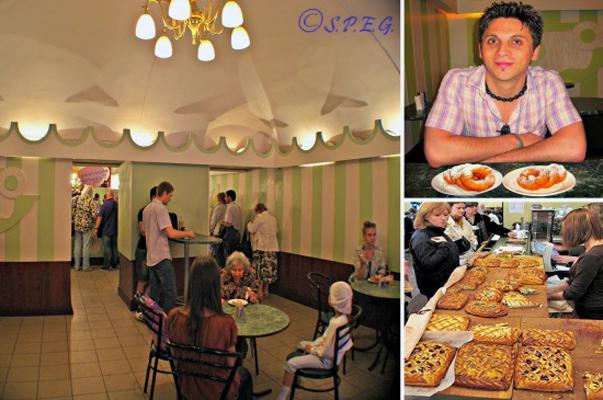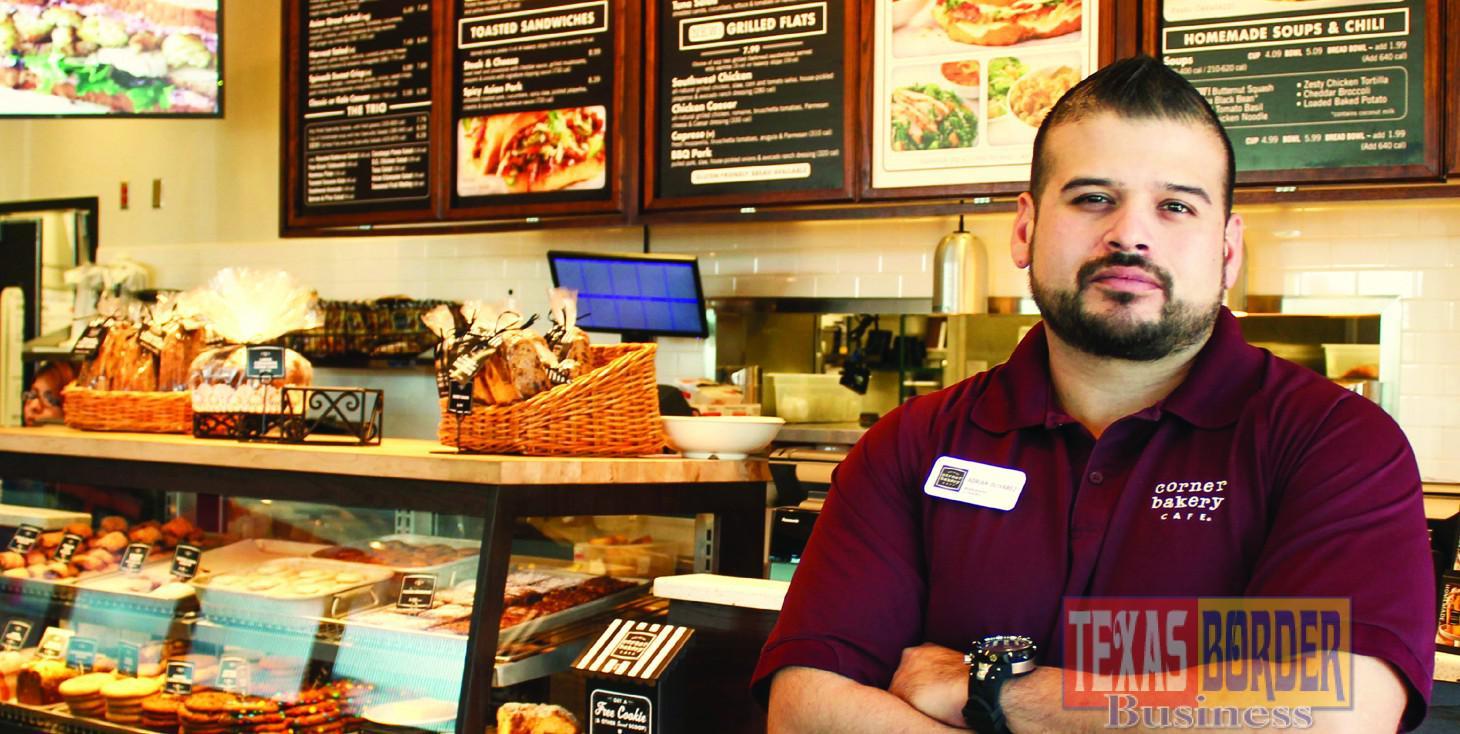The first image is the image on the left, the second image is the image on the right. Given the left and right images, does the statement "There are more women than there are men." hold true? Answer yes or no. No. The first image is the image on the left, the second image is the image on the right. For the images shown, is this caption "Has atleast one picture of a lone bearded man" true? Answer yes or no. Yes. 